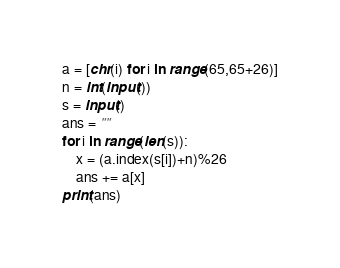Convert code to text. <code><loc_0><loc_0><loc_500><loc_500><_Python_>a = [chr(i) for i in range(65,65+26)]
n = int(input())
s = input()
ans = ""
for i in range(len(s)):
    x = (a.index(s[i])+n)%26
    ans += a[x]
print(ans)</code> 